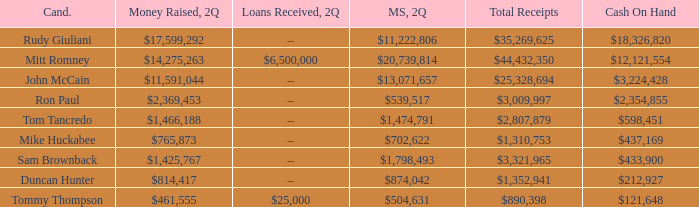Name the loans received for 2Q having total receipts of $25,328,694 –. 